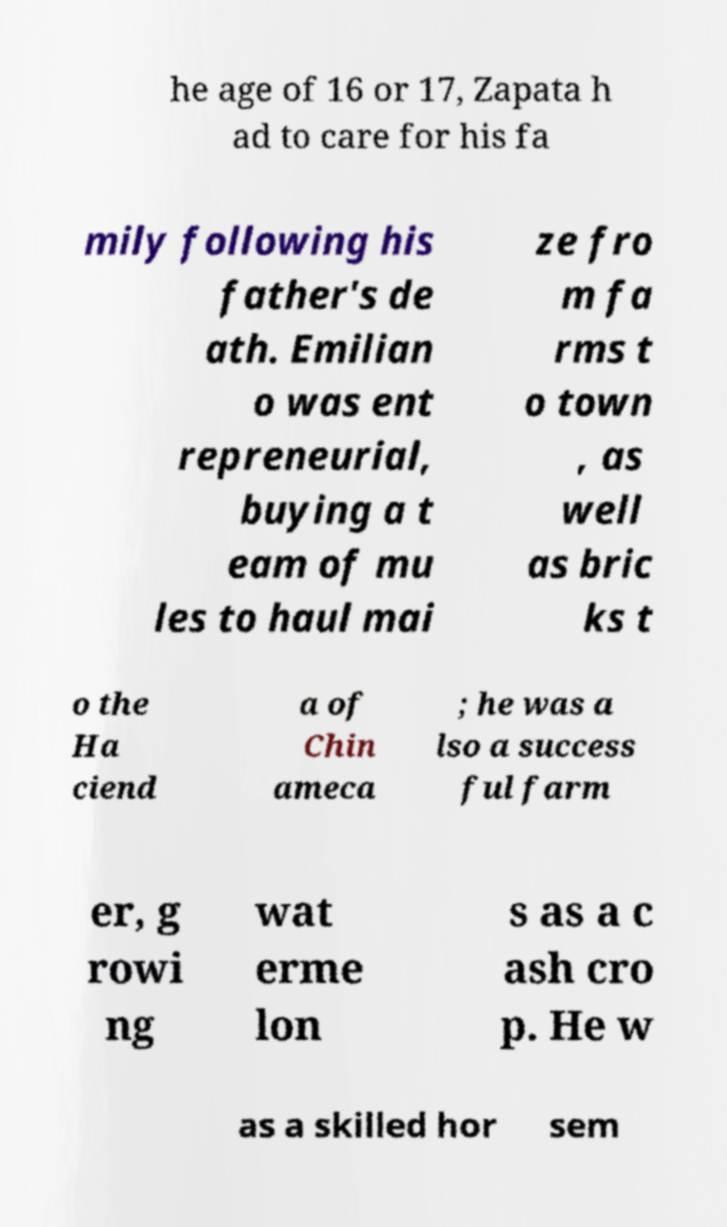Can you accurately transcribe the text from the provided image for me? he age of 16 or 17, Zapata h ad to care for his fa mily following his father's de ath. Emilian o was ent repreneurial, buying a t eam of mu les to haul mai ze fro m fa rms t o town , as well as bric ks t o the Ha ciend a of Chin ameca ; he was a lso a success ful farm er, g rowi ng wat erme lon s as a c ash cro p. He w as a skilled hor sem 